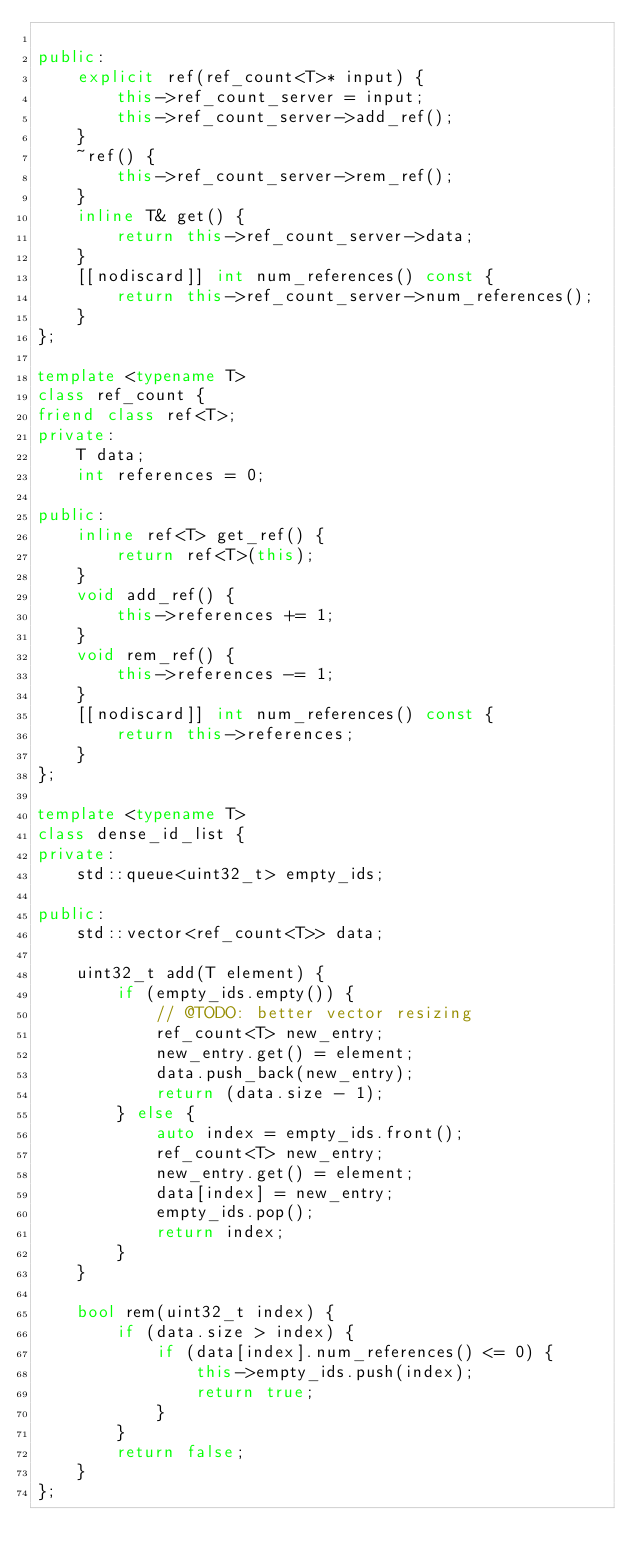<code> <loc_0><loc_0><loc_500><loc_500><_C++_>
public:
    explicit ref(ref_count<T>* input) {
        this->ref_count_server = input;
        this->ref_count_server->add_ref();
    }
    ~ref() {
        this->ref_count_server->rem_ref();
    }
    inline T& get() {
        return this->ref_count_server->data;
    }
    [[nodiscard]] int num_references() const {
        return this->ref_count_server->num_references();
    }
};

template <typename T>
class ref_count {
friend class ref<T>;
private:
    T data;
    int references = 0;

public:
    inline ref<T> get_ref() {
        return ref<T>(this);
    }
    void add_ref() {
        this->references += 1;
    }
    void rem_ref() {
        this->references -= 1;
    }
    [[nodiscard]] int num_references() const {
        return this->references;
    }
};

template <typename T>
class dense_id_list {
private:
    std::queue<uint32_t> empty_ids;

public:
    std::vector<ref_count<T>> data;

    uint32_t add(T element) {
        if (empty_ids.empty()) {
            // @TODO: better vector resizing
            ref_count<T> new_entry;
            new_entry.get() = element;
            data.push_back(new_entry);
            return (data.size - 1);
        } else {
            auto index = empty_ids.front();
            ref_count<T> new_entry;
            new_entry.get() = element;
            data[index] = new_entry;
            empty_ids.pop();
            return index;
        }
    }

    bool rem(uint32_t index) {
        if (data.size > index) {
            if (data[index].num_references() <= 0) {
                this->empty_ids.push(index);
                return true;
            }
        }
        return false;
    }
};
</code> 